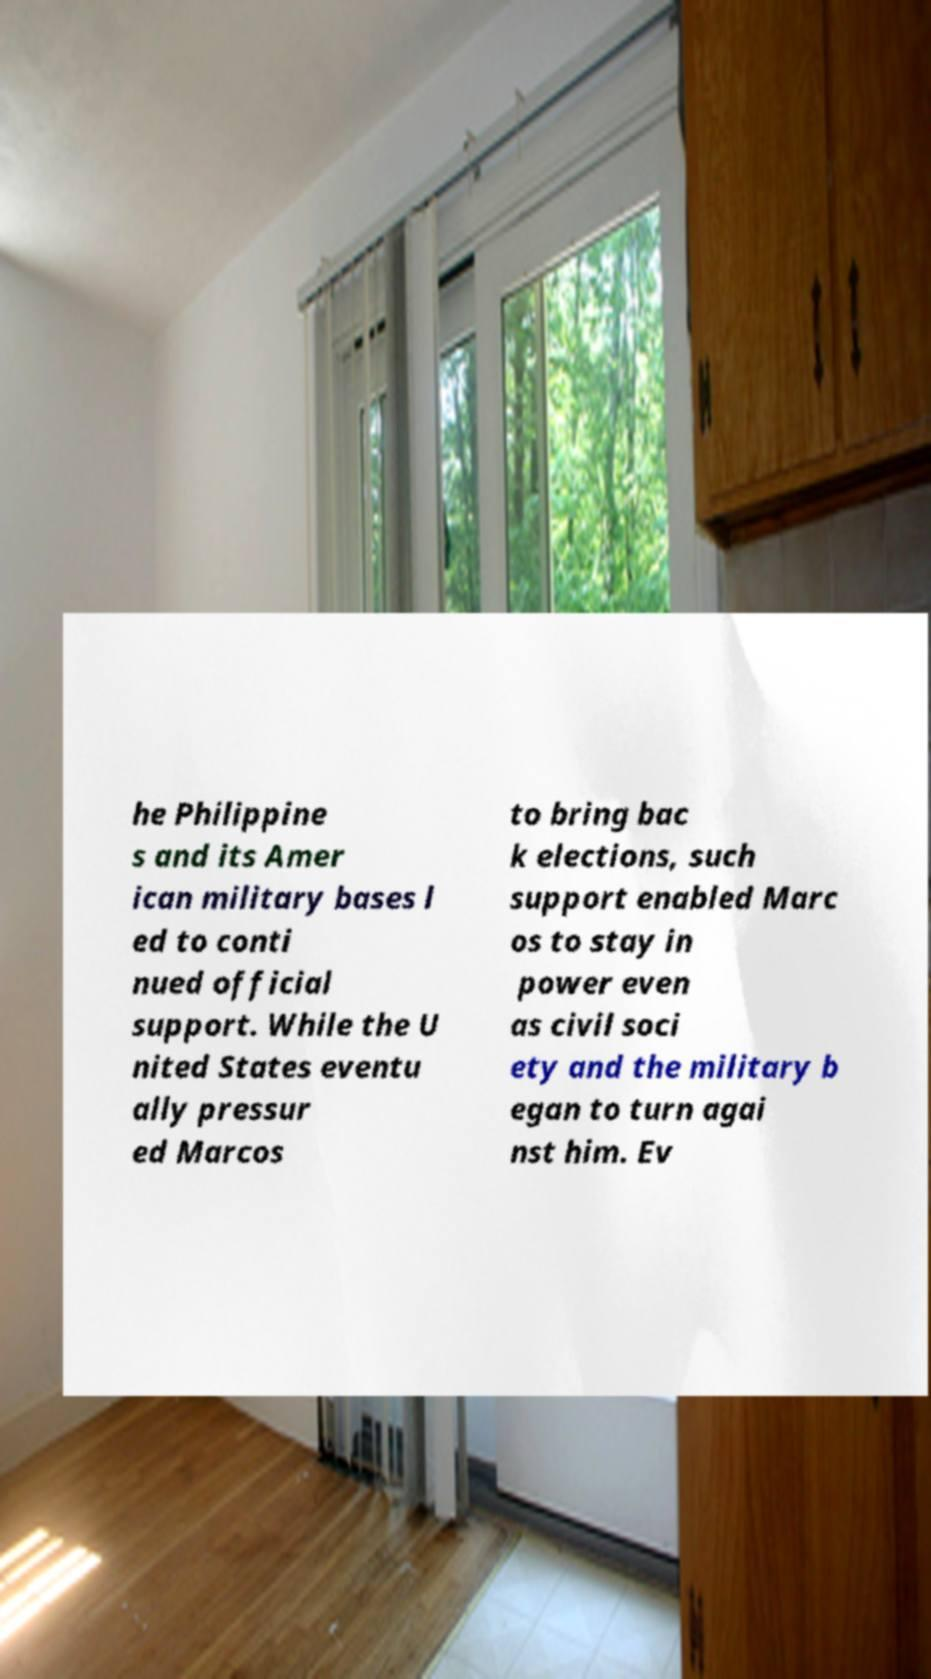Please identify and transcribe the text found in this image. he Philippine s and its Amer ican military bases l ed to conti nued official support. While the U nited States eventu ally pressur ed Marcos to bring bac k elections, such support enabled Marc os to stay in power even as civil soci ety and the military b egan to turn agai nst him. Ev 